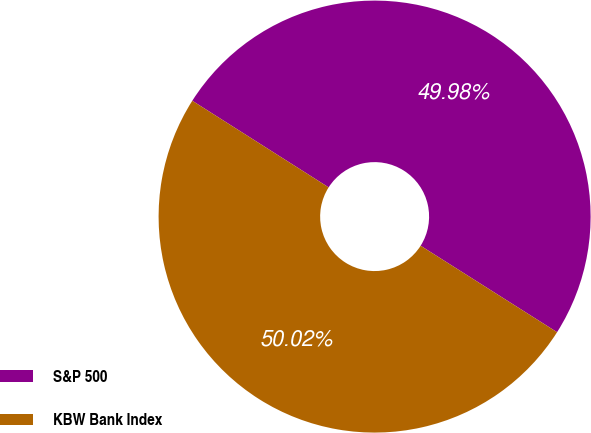<chart> <loc_0><loc_0><loc_500><loc_500><pie_chart><fcel>S&P 500<fcel>KBW Bank Index<nl><fcel>49.98%<fcel>50.02%<nl></chart> 